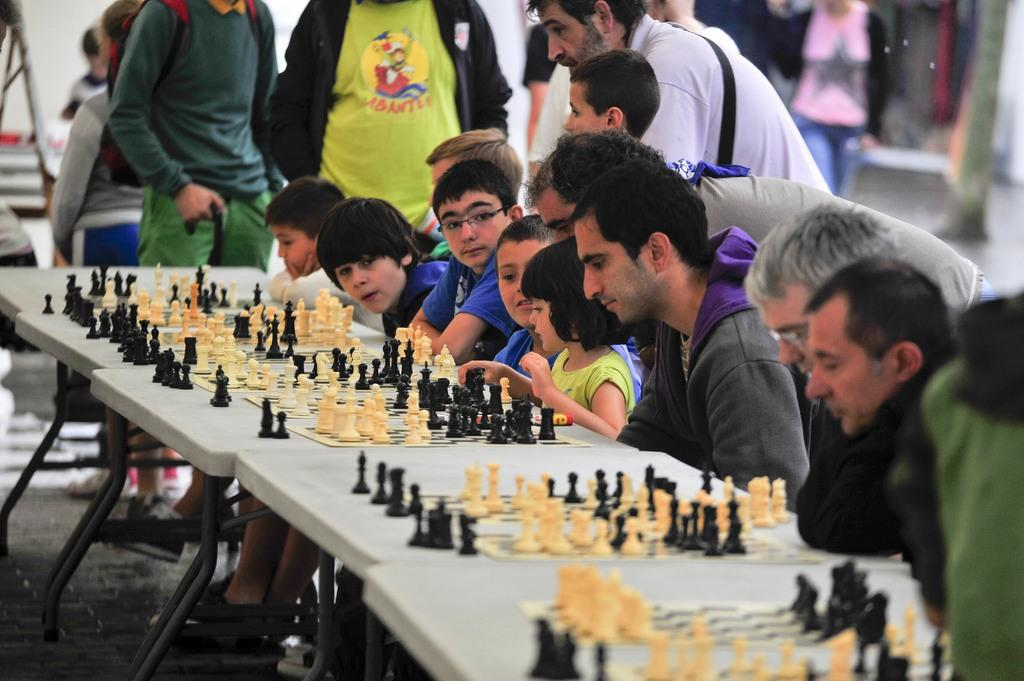What are the people in the image doing? Some people are sitting and some are standing in the image. What can be seen on the tables in the image? There are chess boards and coins placed on the tables. What type of idea is being discussed by the people in the image? There is no indication in the image of any ideas being discussed; the focus is on the people's positions and the objects on the tables. 